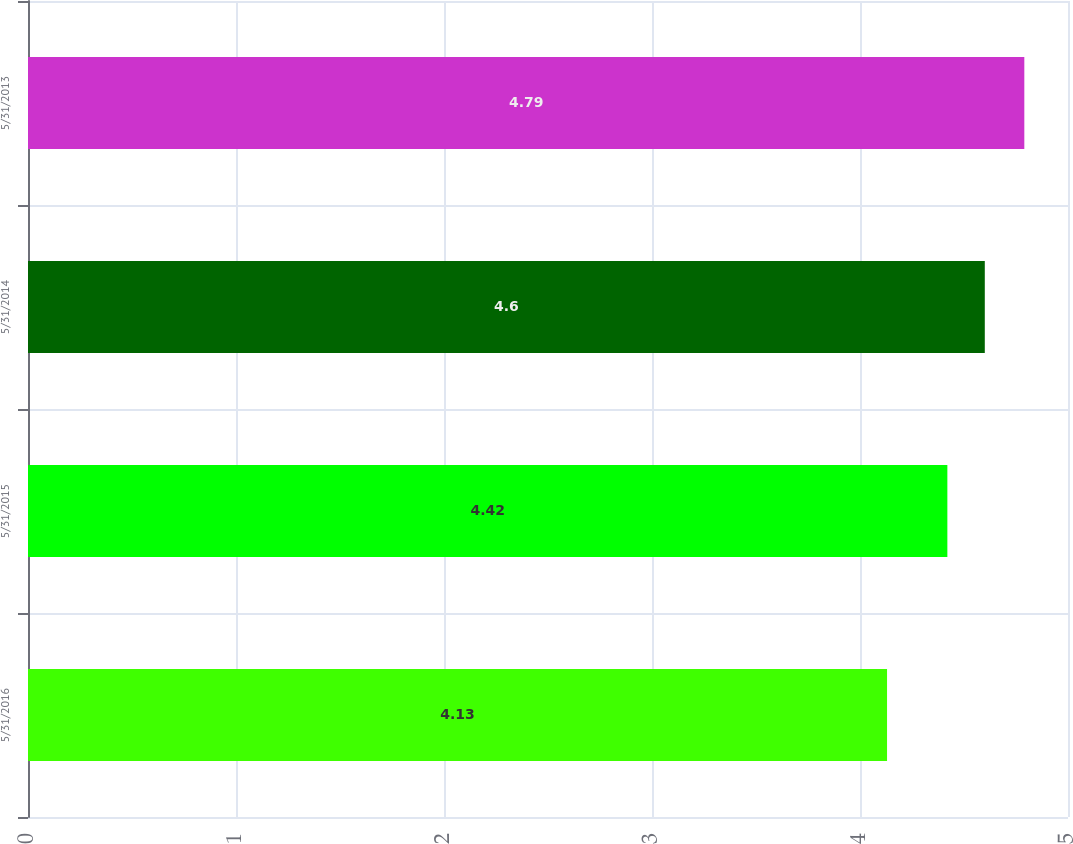Convert chart. <chart><loc_0><loc_0><loc_500><loc_500><bar_chart><fcel>5/31/2016<fcel>5/31/2015<fcel>5/31/2014<fcel>5/31/2013<nl><fcel>4.13<fcel>4.42<fcel>4.6<fcel>4.79<nl></chart> 